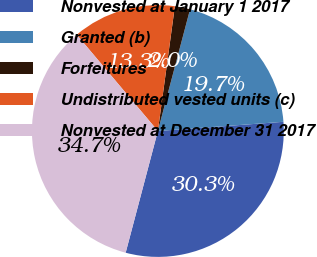<chart> <loc_0><loc_0><loc_500><loc_500><pie_chart><fcel>Nonvested at January 1 2017<fcel>Granted (b)<fcel>Forfeitures<fcel>Undistributed vested units (c)<fcel>Nonvested at December 31 2017<nl><fcel>30.28%<fcel>19.72%<fcel>1.96%<fcel>13.3%<fcel>34.74%<nl></chart> 